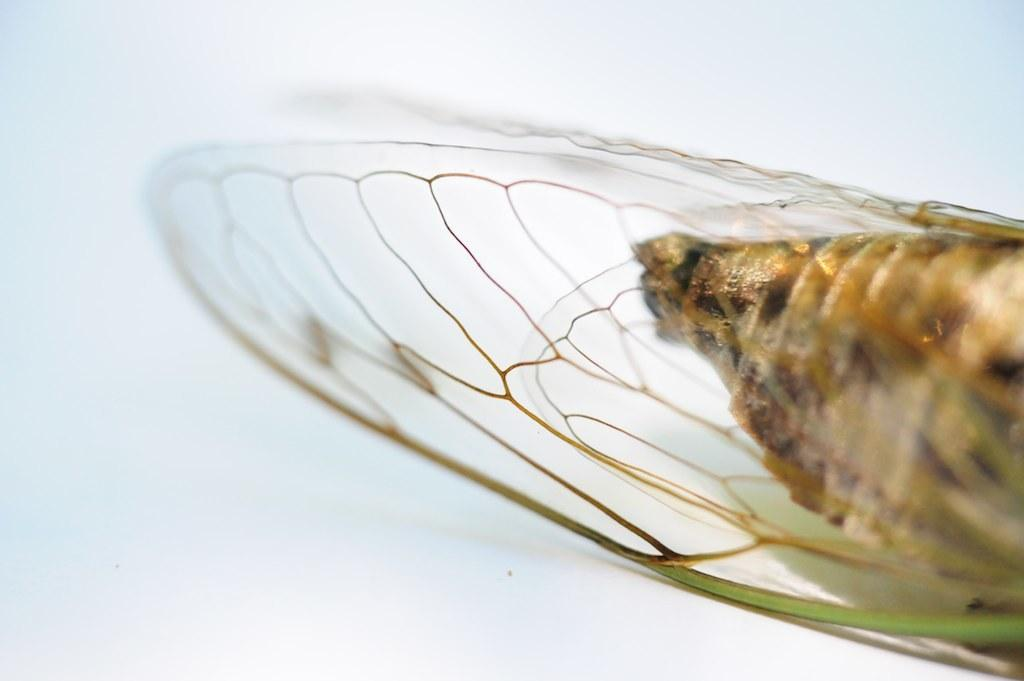What type of creature can be seen in the image? There is an insect in the image. What color is the background of the image? The background of the image is white. What type of dish is the cook preparing in the image? There is no cook or dish preparation present in the image; it only features an insect and a white background. 